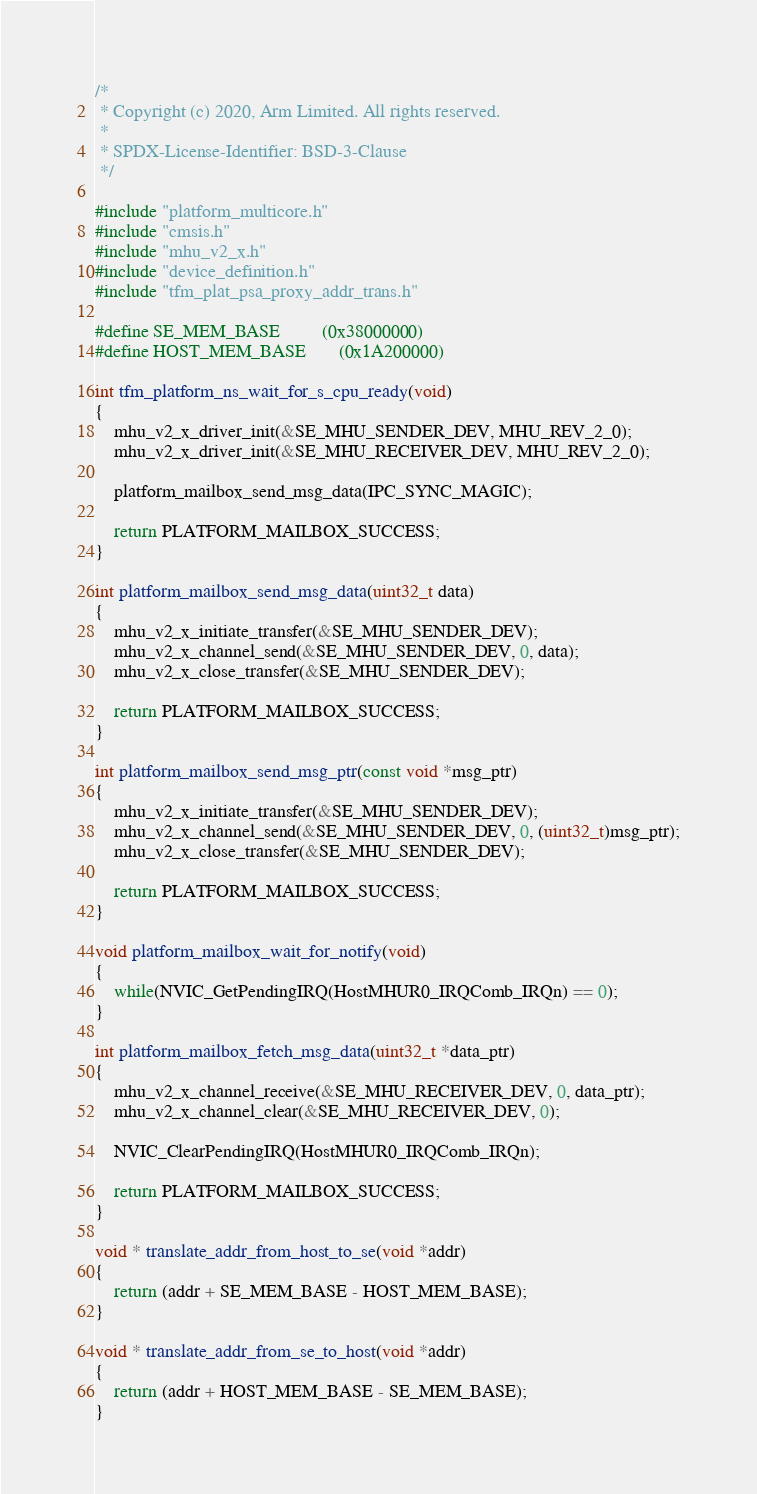Convert code to text. <code><loc_0><loc_0><loc_500><loc_500><_C_>/*
 * Copyright (c) 2020, Arm Limited. All rights reserved.
 *
 * SPDX-License-Identifier: BSD-3-Clause
 */

#include "platform_multicore.h"
#include "cmsis.h"
#include "mhu_v2_x.h"
#include "device_definition.h"
#include "tfm_plat_psa_proxy_addr_trans.h"

#define SE_MEM_BASE         (0x38000000)
#define HOST_MEM_BASE       (0x1A200000)

int tfm_platform_ns_wait_for_s_cpu_ready(void)
{
    mhu_v2_x_driver_init(&SE_MHU_SENDER_DEV, MHU_REV_2_0);
    mhu_v2_x_driver_init(&SE_MHU_RECEIVER_DEV, MHU_REV_2_0);

    platform_mailbox_send_msg_data(IPC_SYNC_MAGIC);

    return PLATFORM_MAILBOX_SUCCESS;
}

int platform_mailbox_send_msg_data(uint32_t data)
{
    mhu_v2_x_initiate_transfer(&SE_MHU_SENDER_DEV);
    mhu_v2_x_channel_send(&SE_MHU_SENDER_DEV, 0, data);
    mhu_v2_x_close_transfer(&SE_MHU_SENDER_DEV);

    return PLATFORM_MAILBOX_SUCCESS;
}

int platform_mailbox_send_msg_ptr(const void *msg_ptr)
{
    mhu_v2_x_initiate_transfer(&SE_MHU_SENDER_DEV);
    mhu_v2_x_channel_send(&SE_MHU_SENDER_DEV, 0, (uint32_t)msg_ptr);
    mhu_v2_x_close_transfer(&SE_MHU_SENDER_DEV);

    return PLATFORM_MAILBOX_SUCCESS;
}

void platform_mailbox_wait_for_notify(void)
{
    while(NVIC_GetPendingIRQ(HostMHUR0_IRQComb_IRQn) == 0);
}

int platform_mailbox_fetch_msg_data(uint32_t *data_ptr)
{
    mhu_v2_x_channel_receive(&SE_MHU_RECEIVER_DEV, 0, data_ptr);
    mhu_v2_x_channel_clear(&SE_MHU_RECEIVER_DEV, 0);

    NVIC_ClearPendingIRQ(HostMHUR0_IRQComb_IRQn);

    return PLATFORM_MAILBOX_SUCCESS;
}

void * translate_addr_from_host_to_se(void *addr)
{
    return (addr + SE_MEM_BASE - HOST_MEM_BASE);
}

void * translate_addr_from_se_to_host(void *addr)
{
    return (addr + HOST_MEM_BASE - SE_MEM_BASE);
}
</code> 